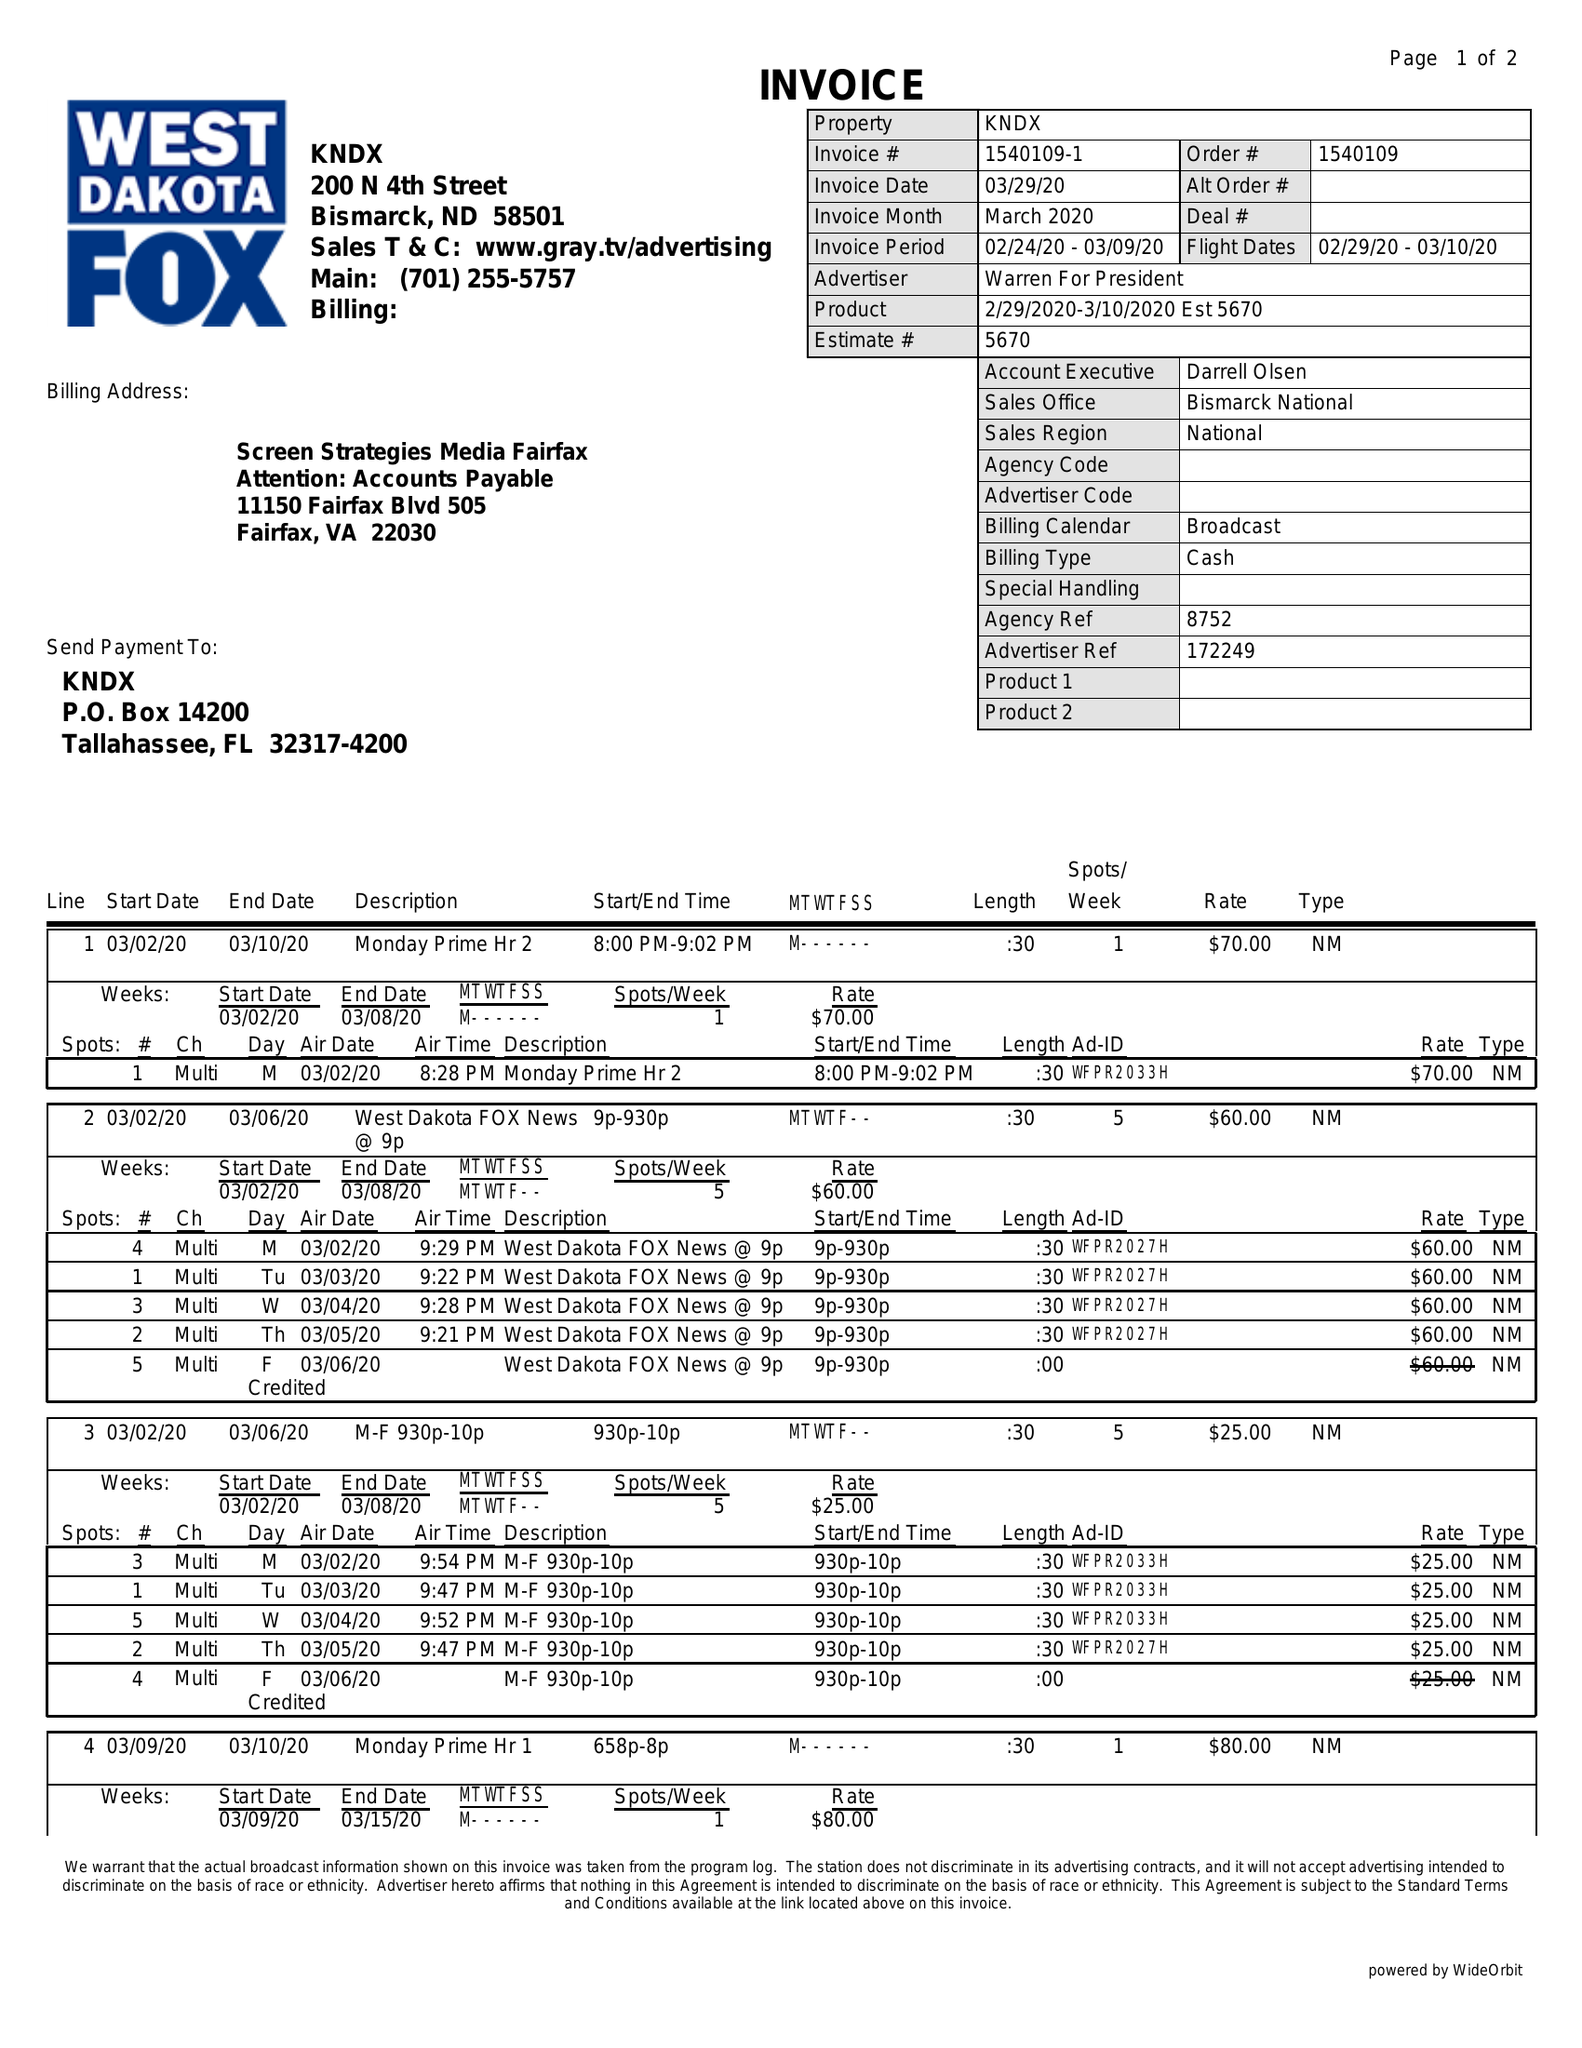What is the value for the gross_amount?
Answer the question using a single word or phrase. 410.00 